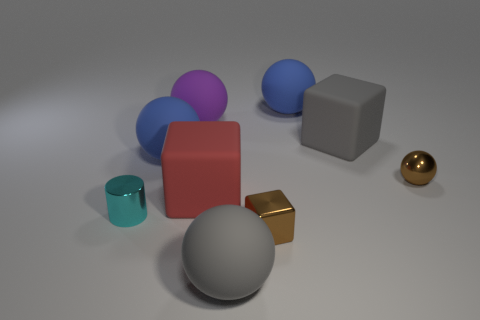Subtract all purple matte spheres. How many spheres are left? 4 Subtract all cyan spheres. Subtract all gray cylinders. How many spheres are left? 5 Add 1 large blue rubber objects. How many objects exist? 10 Subtract all blocks. How many objects are left? 6 Subtract all red objects. Subtract all small cyan cylinders. How many objects are left? 7 Add 1 balls. How many balls are left? 6 Add 1 small brown objects. How many small brown objects exist? 3 Subtract 1 cyan cylinders. How many objects are left? 8 